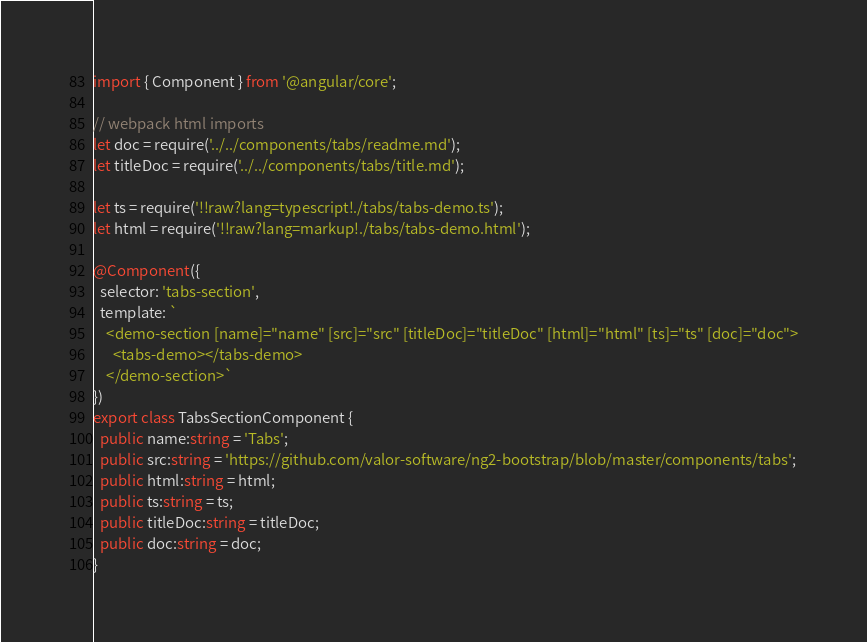<code> <loc_0><loc_0><loc_500><loc_500><_TypeScript_>import { Component } from '@angular/core';

// webpack html imports
let doc = require('../../components/tabs/readme.md');
let titleDoc = require('../../components/tabs/title.md');

let ts = require('!!raw?lang=typescript!./tabs/tabs-demo.ts');
let html = require('!!raw?lang=markup!./tabs/tabs-demo.html');

@Component({
  selector: 'tabs-section',
  template: `
    <demo-section [name]="name" [src]="src" [titleDoc]="titleDoc" [html]="html" [ts]="ts" [doc]="doc">
      <tabs-demo></tabs-demo>
    </demo-section>`
})
export class TabsSectionComponent {
  public name:string = 'Tabs';
  public src:string = 'https://github.com/valor-software/ng2-bootstrap/blob/master/components/tabs';
  public html:string = html;
  public ts:string = ts;
  public titleDoc:string = titleDoc;
  public doc:string = doc;
}
</code> 